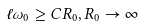<formula> <loc_0><loc_0><loc_500><loc_500>\ell \omega _ { 0 } \geq C R _ { 0 } , R _ { 0 } \to \infty</formula> 